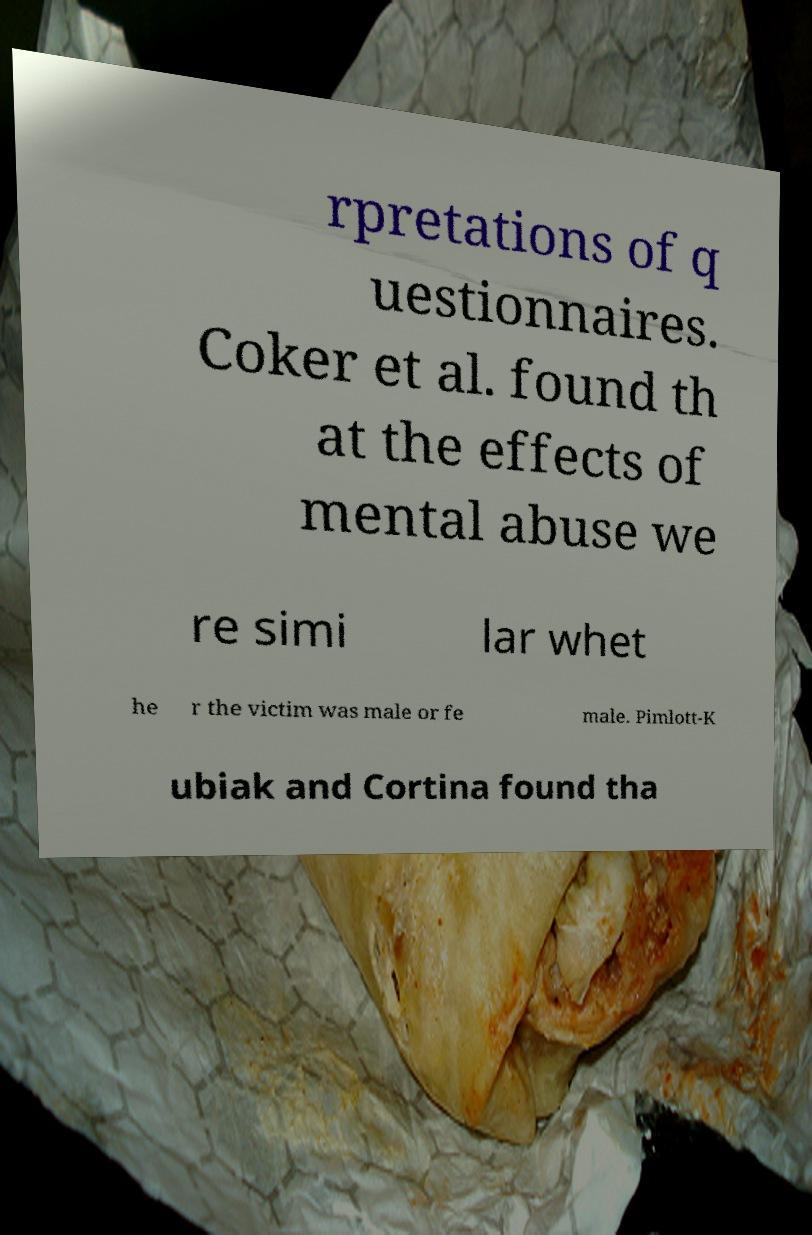There's text embedded in this image that I need extracted. Can you transcribe it verbatim? rpretations of q uestionnaires. Coker et al. found th at the effects of mental abuse we re simi lar whet he r the victim was male or fe male. Pimlott-K ubiak and Cortina found tha 